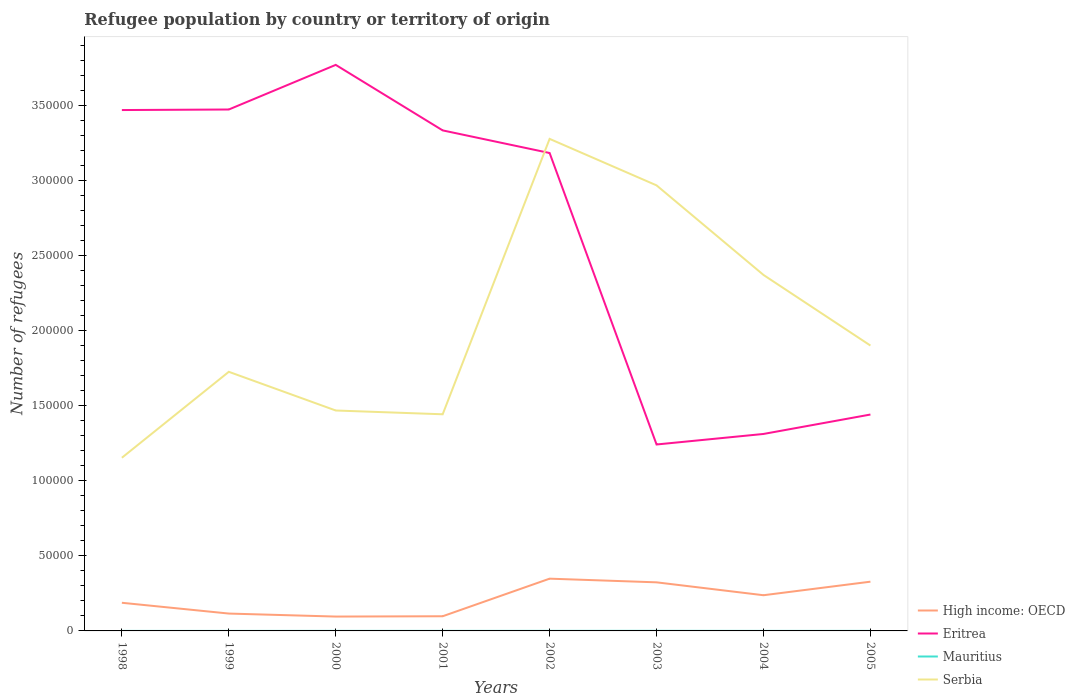How many different coloured lines are there?
Your answer should be compact. 4. Does the line corresponding to High income: OECD intersect with the line corresponding to Mauritius?
Your response must be concise. No. Is the number of lines equal to the number of legend labels?
Offer a terse response. Yes. Across all years, what is the maximum number of refugees in High income: OECD?
Ensure brevity in your answer.  9560. What is the total number of refugees in High income: OECD in the graph?
Provide a succinct answer. 1789. What is the difference between the highest and the second highest number of refugees in High income: OECD?
Offer a very short reply. 2.52e+04. What is the difference between the highest and the lowest number of refugees in Mauritius?
Keep it short and to the point. 4. Are the values on the major ticks of Y-axis written in scientific E-notation?
Offer a terse response. No. How many legend labels are there?
Your answer should be compact. 4. How are the legend labels stacked?
Give a very brief answer. Vertical. What is the title of the graph?
Give a very brief answer. Refugee population by country or territory of origin. What is the label or title of the Y-axis?
Provide a short and direct response. Number of refugees. What is the Number of refugees in High income: OECD in 1998?
Your response must be concise. 1.87e+04. What is the Number of refugees in Eritrea in 1998?
Your answer should be compact. 3.47e+05. What is the Number of refugees of Serbia in 1998?
Give a very brief answer. 1.15e+05. What is the Number of refugees of High income: OECD in 1999?
Your response must be concise. 1.16e+04. What is the Number of refugees of Eritrea in 1999?
Provide a succinct answer. 3.47e+05. What is the Number of refugees in Mauritius in 1999?
Make the answer very short. 8. What is the Number of refugees of Serbia in 1999?
Give a very brief answer. 1.73e+05. What is the Number of refugees of High income: OECD in 2000?
Your response must be concise. 9560. What is the Number of refugees of Eritrea in 2000?
Your answer should be very brief. 3.77e+05. What is the Number of refugees of Mauritius in 2000?
Keep it short and to the point. 35. What is the Number of refugees in Serbia in 2000?
Offer a terse response. 1.47e+05. What is the Number of refugees of High income: OECD in 2001?
Give a very brief answer. 9772. What is the Number of refugees of Eritrea in 2001?
Provide a succinct answer. 3.33e+05. What is the Number of refugees of Serbia in 2001?
Ensure brevity in your answer.  1.44e+05. What is the Number of refugees in High income: OECD in 2002?
Offer a terse response. 3.48e+04. What is the Number of refugees of Eritrea in 2002?
Ensure brevity in your answer.  3.18e+05. What is the Number of refugees of Serbia in 2002?
Your response must be concise. 3.28e+05. What is the Number of refugees in High income: OECD in 2003?
Ensure brevity in your answer.  3.23e+04. What is the Number of refugees in Eritrea in 2003?
Your answer should be very brief. 1.24e+05. What is the Number of refugees of Mauritius in 2003?
Keep it short and to the point. 61. What is the Number of refugees in Serbia in 2003?
Offer a terse response. 2.97e+05. What is the Number of refugees of High income: OECD in 2004?
Provide a succinct answer. 2.38e+04. What is the Number of refugees in Eritrea in 2004?
Offer a very short reply. 1.31e+05. What is the Number of refugees of Mauritius in 2004?
Ensure brevity in your answer.  19. What is the Number of refugees in Serbia in 2004?
Keep it short and to the point. 2.37e+05. What is the Number of refugees in High income: OECD in 2005?
Your answer should be compact. 3.28e+04. What is the Number of refugees of Eritrea in 2005?
Offer a very short reply. 1.44e+05. What is the Number of refugees in Serbia in 2005?
Give a very brief answer. 1.90e+05. Across all years, what is the maximum Number of refugees of High income: OECD?
Your answer should be compact. 3.48e+04. Across all years, what is the maximum Number of refugees in Eritrea?
Offer a very short reply. 3.77e+05. Across all years, what is the maximum Number of refugees of Mauritius?
Keep it short and to the point. 61. Across all years, what is the maximum Number of refugees of Serbia?
Provide a succinct answer. 3.28e+05. Across all years, what is the minimum Number of refugees of High income: OECD?
Make the answer very short. 9560. Across all years, what is the minimum Number of refugees of Eritrea?
Your answer should be very brief. 1.24e+05. Across all years, what is the minimum Number of refugees of Serbia?
Your answer should be very brief. 1.15e+05. What is the total Number of refugees of High income: OECD in the graph?
Give a very brief answer. 1.73e+05. What is the total Number of refugees of Eritrea in the graph?
Offer a very short reply. 2.12e+06. What is the total Number of refugees in Mauritius in the graph?
Your answer should be compact. 243. What is the total Number of refugees of Serbia in the graph?
Provide a short and direct response. 1.63e+06. What is the difference between the Number of refugees of High income: OECD in 1998 and that in 1999?
Make the answer very short. 7180. What is the difference between the Number of refugees of Eritrea in 1998 and that in 1999?
Offer a terse response. -357. What is the difference between the Number of refugees of Mauritius in 1998 and that in 1999?
Keep it short and to the point. 7. What is the difference between the Number of refugees of Serbia in 1998 and that in 1999?
Give a very brief answer. -5.72e+04. What is the difference between the Number of refugees in High income: OECD in 1998 and that in 2000?
Provide a succinct answer. 9181. What is the difference between the Number of refugees of Eritrea in 1998 and that in 2000?
Offer a very short reply. -3.01e+04. What is the difference between the Number of refugees of Mauritius in 1998 and that in 2000?
Offer a terse response. -20. What is the difference between the Number of refugees of Serbia in 1998 and that in 2000?
Your answer should be very brief. -3.15e+04. What is the difference between the Number of refugees of High income: OECD in 1998 and that in 2001?
Your answer should be compact. 8969. What is the difference between the Number of refugees of Eritrea in 1998 and that in 2001?
Make the answer very short. 1.36e+04. What is the difference between the Number of refugees of Serbia in 1998 and that in 2001?
Provide a succinct answer. -2.89e+04. What is the difference between the Number of refugees of High income: OECD in 1998 and that in 2002?
Provide a short and direct response. -1.60e+04. What is the difference between the Number of refugees in Eritrea in 1998 and that in 2002?
Offer a terse response. 2.86e+04. What is the difference between the Number of refugees of Serbia in 1998 and that in 2002?
Offer a terse response. -2.12e+05. What is the difference between the Number of refugees in High income: OECD in 1998 and that in 2003?
Keep it short and to the point. -1.36e+04. What is the difference between the Number of refugees in Eritrea in 1998 and that in 2003?
Your answer should be compact. 2.23e+05. What is the difference between the Number of refugees in Mauritius in 1998 and that in 2003?
Your answer should be very brief. -46. What is the difference between the Number of refugees of Serbia in 1998 and that in 2003?
Offer a very short reply. -1.81e+05. What is the difference between the Number of refugees in High income: OECD in 1998 and that in 2004?
Provide a short and direct response. -5022. What is the difference between the Number of refugees of Eritrea in 1998 and that in 2004?
Your response must be concise. 2.16e+05. What is the difference between the Number of refugees of Serbia in 1998 and that in 2004?
Offer a terse response. -1.22e+05. What is the difference between the Number of refugees of High income: OECD in 1998 and that in 2005?
Provide a short and direct response. -1.40e+04. What is the difference between the Number of refugees in Eritrea in 1998 and that in 2005?
Provide a succinct answer. 2.03e+05. What is the difference between the Number of refugees in Serbia in 1998 and that in 2005?
Keep it short and to the point. -7.47e+04. What is the difference between the Number of refugees of High income: OECD in 1999 and that in 2000?
Make the answer very short. 2001. What is the difference between the Number of refugees in Eritrea in 1999 and that in 2000?
Ensure brevity in your answer.  -2.97e+04. What is the difference between the Number of refugees in Serbia in 1999 and that in 2000?
Your answer should be compact. 2.58e+04. What is the difference between the Number of refugees of High income: OECD in 1999 and that in 2001?
Your response must be concise. 1789. What is the difference between the Number of refugees of Eritrea in 1999 and that in 2001?
Your answer should be compact. 1.39e+04. What is the difference between the Number of refugees in Serbia in 1999 and that in 2001?
Your response must be concise. 2.83e+04. What is the difference between the Number of refugees in High income: OECD in 1999 and that in 2002?
Give a very brief answer. -2.32e+04. What is the difference between the Number of refugees of Eritrea in 1999 and that in 2002?
Your answer should be very brief. 2.90e+04. What is the difference between the Number of refugees of Mauritius in 1999 and that in 2002?
Offer a very short reply. -35. What is the difference between the Number of refugees of Serbia in 1999 and that in 2002?
Your response must be concise. -1.55e+05. What is the difference between the Number of refugees in High income: OECD in 1999 and that in 2003?
Make the answer very short. -2.08e+04. What is the difference between the Number of refugees of Eritrea in 1999 and that in 2003?
Ensure brevity in your answer.  2.23e+05. What is the difference between the Number of refugees of Mauritius in 1999 and that in 2003?
Provide a succinct answer. -53. What is the difference between the Number of refugees in Serbia in 1999 and that in 2003?
Make the answer very short. -1.24e+05. What is the difference between the Number of refugees of High income: OECD in 1999 and that in 2004?
Your answer should be compact. -1.22e+04. What is the difference between the Number of refugees in Eritrea in 1999 and that in 2004?
Provide a short and direct response. 2.16e+05. What is the difference between the Number of refugees of Mauritius in 1999 and that in 2004?
Your answer should be very brief. -11. What is the difference between the Number of refugees in Serbia in 1999 and that in 2004?
Ensure brevity in your answer.  -6.45e+04. What is the difference between the Number of refugees of High income: OECD in 1999 and that in 2005?
Offer a terse response. -2.12e+04. What is the difference between the Number of refugees in Eritrea in 1999 and that in 2005?
Keep it short and to the point. 2.03e+05. What is the difference between the Number of refugees of Mauritius in 1999 and that in 2005?
Make the answer very short. -19. What is the difference between the Number of refugees of Serbia in 1999 and that in 2005?
Offer a very short reply. -1.75e+04. What is the difference between the Number of refugees in High income: OECD in 2000 and that in 2001?
Provide a short and direct response. -212. What is the difference between the Number of refugees in Eritrea in 2000 and that in 2001?
Keep it short and to the point. 4.36e+04. What is the difference between the Number of refugees of Serbia in 2000 and that in 2001?
Your answer should be compact. 2517. What is the difference between the Number of refugees in High income: OECD in 2000 and that in 2002?
Provide a succinct answer. -2.52e+04. What is the difference between the Number of refugees of Eritrea in 2000 and that in 2002?
Make the answer very short. 5.87e+04. What is the difference between the Number of refugees of Mauritius in 2000 and that in 2002?
Your answer should be very brief. -8. What is the difference between the Number of refugees in Serbia in 2000 and that in 2002?
Offer a very short reply. -1.81e+05. What is the difference between the Number of refugees in High income: OECD in 2000 and that in 2003?
Provide a short and direct response. -2.28e+04. What is the difference between the Number of refugees in Eritrea in 2000 and that in 2003?
Make the answer very short. 2.53e+05. What is the difference between the Number of refugees in Serbia in 2000 and that in 2003?
Provide a succinct answer. -1.50e+05. What is the difference between the Number of refugees of High income: OECD in 2000 and that in 2004?
Give a very brief answer. -1.42e+04. What is the difference between the Number of refugees of Eritrea in 2000 and that in 2004?
Offer a terse response. 2.46e+05. What is the difference between the Number of refugees of Mauritius in 2000 and that in 2004?
Ensure brevity in your answer.  16. What is the difference between the Number of refugees of Serbia in 2000 and that in 2004?
Your response must be concise. -9.03e+04. What is the difference between the Number of refugees in High income: OECD in 2000 and that in 2005?
Offer a terse response. -2.32e+04. What is the difference between the Number of refugees in Eritrea in 2000 and that in 2005?
Keep it short and to the point. 2.33e+05. What is the difference between the Number of refugees of Serbia in 2000 and that in 2005?
Your answer should be compact. -4.32e+04. What is the difference between the Number of refugees of High income: OECD in 2001 and that in 2002?
Make the answer very short. -2.50e+04. What is the difference between the Number of refugees in Eritrea in 2001 and that in 2002?
Give a very brief answer. 1.51e+04. What is the difference between the Number of refugees in Mauritius in 2001 and that in 2002?
Offer a very short reply. -8. What is the difference between the Number of refugees in Serbia in 2001 and that in 2002?
Give a very brief answer. -1.83e+05. What is the difference between the Number of refugees in High income: OECD in 2001 and that in 2003?
Offer a terse response. -2.26e+04. What is the difference between the Number of refugees of Eritrea in 2001 and that in 2003?
Offer a very short reply. 2.09e+05. What is the difference between the Number of refugees of Mauritius in 2001 and that in 2003?
Offer a very short reply. -26. What is the difference between the Number of refugees in Serbia in 2001 and that in 2003?
Offer a terse response. -1.52e+05. What is the difference between the Number of refugees in High income: OECD in 2001 and that in 2004?
Provide a succinct answer. -1.40e+04. What is the difference between the Number of refugees in Eritrea in 2001 and that in 2004?
Offer a terse response. 2.02e+05. What is the difference between the Number of refugees in Serbia in 2001 and that in 2004?
Offer a terse response. -9.28e+04. What is the difference between the Number of refugees of High income: OECD in 2001 and that in 2005?
Provide a short and direct response. -2.30e+04. What is the difference between the Number of refugees in Eritrea in 2001 and that in 2005?
Ensure brevity in your answer.  1.89e+05. What is the difference between the Number of refugees of Mauritius in 2001 and that in 2005?
Your answer should be compact. 8. What is the difference between the Number of refugees of Serbia in 2001 and that in 2005?
Give a very brief answer. -4.58e+04. What is the difference between the Number of refugees of High income: OECD in 2002 and that in 2003?
Keep it short and to the point. 2445. What is the difference between the Number of refugees of Eritrea in 2002 and that in 2003?
Your answer should be compact. 1.94e+05. What is the difference between the Number of refugees of Mauritius in 2002 and that in 2003?
Offer a terse response. -18. What is the difference between the Number of refugees in Serbia in 2002 and that in 2003?
Offer a very short reply. 3.10e+04. What is the difference between the Number of refugees of High income: OECD in 2002 and that in 2004?
Ensure brevity in your answer.  1.10e+04. What is the difference between the Number of refugees in Eritrea in 2002 and that in 2004?
Your answer should be very brief. 1.87e+05. What is the difference between the Number of refugees in Serbia in 2002 and that in 2004?
Offer a terse response. 9.06e+04. What is the difference between the Number of refugees in High income: OECD in 2002 and that in 2005?
Keep it short and to the point. 2007. What is the difference between the Number of refugees of Eritrea in 2002 and that in 2005?
Keep it short and to the point. 1.74e+05. What is the difference between the Number of refugees of Mauritius in 2002 and that in 2005?
Offer a terse response. 16. What is the difference between the Number of refugees of Serbia in 2002 and that in 2005?
Offer a very short reply. 1.38e+05. What is the difference between the Number of refugees of High income: OECD in 2003 and that in 2004?
Your response must be concise. 8583. What is the difference between the Number of refugees of Eritrea in 2003 and that in 2004?
Ensure brevity in your answer.  -7010. What is the difference between the Number of refugees of Serbia in 2003 and that in 2004?
Keep it short and to the point. 5.96e+04. What is the difference between the Number of refugees in High income: OECD in 2003 and that in 2005?
Give a very brief answer. -438. What is the difference between the Number of refugees of Eritrea in 2003 and that in 2005?
Provide a succinct answer. -1.99e+04. What is the difference between the Number of refugees of Mauritius in 2003 and that in 2005?
Provide a succinct answer. 34. What is the difference between the Number of refugees of Serbia in 2003 and that in 2005?
Your response must be concise. 1.07e+05. What is the difference between the Number of refugees in High income: OECD in 2004 and that in 2005?
Provide a short and direct response. -9021. What is the difference between the Number of refugees in Eritrea in 2004 and that in 2005?
Your response must be concise. -1.29e+04. What is the difference between the Number of refugees of Serbia in 2004 and that in 2005?
Give a very brief answer. 4.70e+04. What is the difference between the Number of refugees of High income: OECD in 1998 and the Number of refugees of Eritrea in 1999?
Provide a short and direct response. -3.28e+05. What is the difference between the Number of refugees in High income: OECD in 1998 and the Number of refugees in Mauritius in 1999?
Ensure brevity in your answer.  1.87e+04. What is the difference between the Number of refugees of High income: OECD in 1998 and the Number of refugees of Serbia in 1999?
Give a very brief answer. -1.54e+05. What is the difference between the Number of refugees of Eritrea in 1998 and the Number of refugees of Mauritius in 1999?
Keep it short and to the point. 3.47e+05. What is the difference between the Number of refugees of Eritrea in 1998 and the Number of refugees of Serbia in 1999?
Your answer should be very brief. 1.74e+05. What is the difference between the Number of refugees in Mauritius in 1998 and the Number of refugees in Serbia in 1999?
Your response must be concise. -1.72e+05. What is the difference between the Number of refugees of High income: OECD in 1998 and the Number of refugees of Eritrea in 2000?
Provide a succinct answer. -3.58e+05. What is the difference between the Number of refugees of High income: OECD in 1998 and the Number of refugees of Mauritius in 2000?
Provide a succinct answer. 1.87e+04. What is the difference between the Number of refugees in High income: OECD in 1998 and the Number of refugees in Serbia in 2000?
Make the answer very short. -1.28e+05. What is the difference between the Number of refugees of Eritrea in 1998 and the Number of refugees of Mauritius in 2000?
Give a very brief answer. 3.47e+05. What is the difference between the Number of refugees of Eritrea in 1998 and the Number of refugees of Serbia in 2000?
Keep it short and to the point. 2.00e+05. What is the difference between the Number of refugees in Mauritius in 1998 and the Number of refugees in Serbia in 2000?
Ensure brevity in your answer.  -1.47e+05. What is the difference between the Number of refugees in High income: OECD in 1998 and the Number of refugees in Eritrea in 2001?
Offer a very short reply. -3.14e+05. What is the difference between the Number of refugees of High income: OECD in 1998 and the Number of refugees of Mauritius in 2001?
Make the answer very short. 1.87e+04. What is the difference between the Number of refugees of High income: OECD in 1998 and the Number of refugees of Serbia in 2001?
Ensure brevity in your answer.  -1.25e+05. What is the difference between the Number of refugees in Eritrea in 1998 and the Number of refugees in Mauritius in 2001?
Provide a short and direct response. 3.47e+05. What is the difference between the Number of refugees in Eritrea in 1998 and the Number of refugees in Serbia in 2001?
Keep it short and to the point. 2.03e+05. What is the difference between the Number of refugees in Mauritius in 1998 and the Number of refugees in Serbia in 2001?
Give a very brief answer. -1.44e+05. What is the difference between the Number of refugees of High income: OECD in 1998 and the Number of refugees of Eritrea in 2002?
Provide a short and direct response. -2.99e+05. What is the difference between the Number of refugees in High income: OECD in 1998 and the Number of refugees in Mauritius in 2002?
Keep it short and to the point. 1.87e+04. What is the difference between the Number of refugees of High income: OECD in 1998 and the Number of refugees of Serbia in 2002?
Keep it short and to the point. -3.09e+05. What is the difference between the Number of refugees of Eritrea in 1998 and the Number of refugees of Mauritius in 2002?
Provide a short and direct response. 3.47e+05. What is the difference between the Number of refugees of Eritrea in 1998 and the Number of refugees of Serbia in 2002?
Offer a terse response. 1.92e+04. What is the difference between the Number of refugees of Mauritius in 1998 and the Number of refugees of Serbia in 2002?
Make the answer very short. -3.28e+05. What is the difference between the Number of refugees in High income: OECD in 1998 and the Number of refugees in Eritrea in 2003?
Your answer should be very brief. -1.05e+05. What is the difference between the Number of refugees in High income: OECD in 1998 and the Number of refugees in Mauritius in 2003?
Provide a short and direct response. 1.87e+04. What is the difference between the Number of refugees in High income: OECD in 1998 and the Number of refugees in Serbia in 2003?
Make the answer very short. -2.78e+05. What is the difference between the Number of refugees of Eritrea in 1998 and the Number of refugees of Mauritius in 2003?
Provide a short and direct response. 3.47e+05. What is the difference between the Number of refugees in Eritrea in 1998 and the Number of refugees in Serbia in 2003?
Offer a very short reply. 5.01e+04. What is the difference between the Number of refugees of Mauritius in 1998 and the Number of refugees of Serbia in 2003?
Ensure brevity in your answer.  -2.97e+05. What is the difference between the Number of refugees of High income: OECD in 1998 and the Number of refugees of Eritrea in 2004?
Your answer should be compact. -1.12e+05. What is the difference between the Number of refugees in High income: OECD in 1998 and the Number of refugees in Mauritius in 2004?
Your answer should be compact. 1.87e+04. What is the difference between the Number of refugees of High income: OECD in 1998 and the Number of refugees of Serbia in 2004?
Provide a succinct answer. -2.18e+05. What is the difference between the Number of refugees in Eritrea in 1998 and the Number of refugees in Mauritius in 2004?
Offer a very short reply. 3.47e+05. What is the difference between the Number of refugees in Eritrea in 1998 and the Number of refugees in Serbia in 2004?
Offer a terse response. 1.10e+05. What is the difference between the Number of refugees of Mauritius in 1998 and the Number of refugees of Serbia in 2004?
Offer a very short reply. -2.37e+05. What is the difference between the Number of refugees of High income: OECD in 1998 and the Number of refugees of Eritrea in 2005?
Provide a succinct answer. -1.25e+05. What is the difference between the Number of refugees in High income: OECD in 1998 and the Number of refugees in Mauritius in 2005?
Make the answer very short. 1.87e+04. What is the difference between the Number of refugees of High income: OECD in 1998 and the Number of refugees of Serbia in 2005?
Provide a short and direct response. -1.71e+05. What is the difference between the Number of refugees in Eritrea in 1998 and the Number of refugees in Mauritius in 2005?
Offer a terse response. 3.47e+05. What is the difference between the Number of refugees in Eritrea in 1998 and the Number of refugees in Serbia in 2005?
Your answer should be very brief. 1.57e+05. What is the difference between the Number of refugees of Mauritius in 1998 and the Number of refugees of Serbia in 2005?
Keep it short and to the point. -1.90e+05. What is the difference between the Number of refugees of High income: OECD in 1999 and the Number of refugees of Eritrea in 2000?
Keep it short and to the point. -3.65e+05. What is the difference between the Number of refugees in High income: OECD in 1999 and the Number of refugees in Mauritius in 2000?
Make the answer very short. 1.15e+04. What is the difference between the Number of refugees of High income: OECD in 1999 and the Number of refugees of Serbia in 2000?
Provide a short and direct response. -1.35e+05. What is the difference between the Number of refugees in Eritrea in 1999 and the Number of refugees in Mauritius in 2000?
Your answer should be very brief. 3.47e+05. What is the difference between the Number of refugees in Eritrea in 1999 and the Number of refugees in Serbia in 2000?
Provide a succinct answer. 2.00e+05. What is the difference between the Number of refugees in Mauritius in 1999 and the Number of refugees in Serbia in 2000?
Your response must be concise. -1.47e+05. What is the difference between the Number of refugees in High income: OECD in 1999 and the Number of refugees in Eritrea in 2001?
Give a very brief answer. -3.22e+05. What is the difference between the Number of refugees of High income: OECD in 1999 and the Number of refugees of Mauritius in 2001?
Provide a short and direct response. 1.15e+04. What is the difference between the Number of refugees of High income: OECD in 1999 and the Number of refugees of Serbia in 2001?
Offer a terse response. -1.33e+05. What is the difference between the Number of refugees of Eritrea in 1999 and the Number of refugees of Mauritius in 2001?
Make the answer very short. 3.47e+05. What is the difference between the Number of refugees of Eritrea in 1999 and the Number of refugees of Serbia in 2001?
Your response must be concise. 2.03e+05. What is the difference between the Number of refugees of Mauritius in 1999 and the Number of refugees of Serbia in 2001?
Keep it short and to the point. -1.44e+05. What is the difference between the Number of refugees in High income: OECD in 1999 and the Number of refugees in Eritrea in 2002?
Offer a terse response. -3.07e+05. What is the difference between the Number of refugees of High income: OECD in 1999 and the Number of refugees of Mauritius in 2002?
Offer a very short reply. 1.15e+04. What is the difference between the Number of refugees of High income: OECD in 1999 and the Number of refugees of Serbia in 2002?
Ensure brevity in your answer.  -3.16e+05. What is the difference between the Number of refugees in Eritrea in 1999 and the Number of refugees in Mauritius in 2002?
Your answer should be very brief. 3.47e+05. What is the difference between the Number of refugees in Eritrea in 1999 and the Number of refugees in Serbia in 2002?
Your response must be concise. 1.96e+04. What is the difference between the Number of refugees in Mauritius in 1999 and the Number of refugees in Serbia in 2002?
Make the answer very short. -3.28e+05. What is the difference between the Number of refugees of High income: OECD in 1999 and the Number of refugees of Eritrea in 2003?
Ensure brevity in your answer.  -1.13e+05. What is the difference between the Number of refugees of High income: OECD in 1999 and the Number of refugees of Mauritius in 2003?
Offer a terse response. 1.15e+04. What is the difference between the Number of refugees of High income: OECD in 1999 and the Number of refugees of Serbia in 2003?
Provide a succinct answer. -2.85e+05. What is the difference between the Number of refugees in Eritrea in 1999 and the Number of refugees in Mauritius in 2003?
Provide a short and direct response. 3.47e+05. What is the difference between the Number of refugees in Eritrea in 1999 and the Number of refugees in Serbia in 2003?
Your answer should be compact. 5.05e+04. What is the difference between the Number of refugees of Mauritius in 1999 and the Number of refugees of Serbia in 2003?
Give a very brief answer. -2.97e+05. What is the difference between the Number of refugees in High income: OECD in 1999 and the Number of refugees in Eritrea in 2004?
Keep it short and to the point. -1.20e+05. What is the difference between the Number of refugees of High income: OECD in 1999 and the Number of refugees of Mauritius in 2004?
Keep it short and to the point. 1.15e+04. What is the difference between the Number of refugees of High income: OECD in 1999 and the Number of refugees of Serbia in 2004?
Your answer should be compact. -2.25e+05. What is the difference between the Number of refugees of Eritrea in 1999 and the Number of refugees of Mauritius in 2004?
Give a very brief answer. 3.47e+05. What is the difference between the Number of refugees in Eritrea in 1999 and the Number of refugees in Serbia in 2004?
Ensure brevity in your answer.  1.10e+05. What is the difference between the Number of refugees of Mauritius in 1999 and the Number of refugees of Serbia in 2004?
Make the answer very short. -2.37e+05. What is the difference between the Number of refugees of High income: OECD in 1999 and the Number of refugees of Eritrea in 2005?
Give a very brief answer. -1.33e+05. What is the difference between the Number of refugees of High income: OECD in 1999 and the Number of refugees of Mauritius in 2005?
Give a very brief answer. 1.15e+04. What is the difference between the Number of refugees of High income: OECD in 1999 and the Number of refugees of Serbia in 2005?
Your response must be concise. -1.78e+05. What is the difference between the Number of refugees in Eritrea in 1999 and the Number of refugees in Mauritius in 2005?
Provide a succinct answer. 3.47e+05. What is the difference between the Number of refugees of Eritrea in 1999 and the Number of refugees of Serbia in 2005?
Offer a very short reply. 1.57e+05. What is the difference between the Number of refugees in Mauritius in 1999 and the Number of refugees in Serbia in 2005?
Give a very brief answer. -1.90e+05. What is the difference between the Number of refugees in High income: OECD in 2000 and the Number of refugees in Eritrea in 2001?
Provide a succinct answer. -3.24e+05. What is the difference between the Number of refugees in High income: OECD in 2000 and the Number of refugees in Mauritius in 2001?
Ensure brevity in your answer.  9525. What is the difference between the Number of refugees of High income: OECD in 2000 and the Number of refugees of Serbia in 2001?
Make the answer very short. -1.35e+05. What is the difference between the Number of refugees in Eritrea in 2000 and the Number of refugees in Mauritius in 2001?
Keep it short and to the point. 3.77e+05. What is the difference between the Number of refugees of Eritrea in 2000 and the Number of refugees of Serbia in 2001?
Provide a short and direct response. 2.33e+05. What is the difference between the Number of refugees in Mauritius in 2000 and the Number of refugees in Serbia in 2001?
Offer a very short reply. -1.44e+05. What is the difference between the Number of refugees of High income: OECD in 2000 and the Number of refugees of Eritrea in 2002?
Offer a very short reply. -3.09e+05. What is the difference between the Number of refugees in High income: OECD in 2000 and the Number of refugees in Mauritius in 2002?
Offer a very short reply. 9517. What is the difference between the Number of refugees of High income: OECD in 2000 and the Number of refugees of Serbia in 2002?
Give a very brief answer. -3.18e+05. What is the difference between the Number of refugees in Eritrea in 2000 and the Number of refugees in Mauritius in 2002?
Give a very brief answer. 3.77e+05. What is the difference between the Number of refugees in Eritrea in 2000 and the Number of refugees in Serbia in 2002?
Provide a short and direct response. 4.93e+04. What is the difference between the Number of refugees of Mauritius in 2000 and the Number of refugees of Serbia in 2002?
Give a very brief answer. -3.28e+05. What is the difference between the Number of refugees of High income: OECD in 2000 and the Number of refugees of Eritrea in 2003?
Offer a terse response. -1.15e+05. What is the difference between the Number of refugees in High income: OECD in 2000 and the Number of refugees in Mauritius in 2003?
Provide a succinct answer. 9499. What is the difference between the Number of refugees in High income: OECD in 2000 and the Number of refugees in Serbia in 2003?
Offer a terse response. -2.87e+05. What is the difference between the Number of refugees of Eritrea in 2000 and the Number of refugees of Mauritius in 2003?
Keep it short and to the point. 3.77e+05. What is the difference between the Number of refugees of Eritrea in 2000 and the Number of refugees of Serbia in 2003?
Provide a succinct answer. 8.02e+04. What is the difference between the Number of refugees in Mauritius in 2000 and the Number of refugees in Serbia in 2003?
Provide a succinct answer. -2.97e+05. What is the difference between the Number of refugees of High income: OECD in 2000 and the Number of refugees of Eritrea in 2004?
Make the answer very short. -1.22e+05. What is the difference between the Number of refugees in High income: OECD in 2000 and the Number of refugees in Mauritius in 2004?
Keep it short and to the point. 9541. What is the difference between the Number of refugees in High income: OECD in 2000 and the Number of refugees in Serbia in 2004?
Offer a terse response. -2.27e+05. What is the difference between the Number of refugees in Eritrea in 2000 and the Number of refugees in Mauritius in 2004?
Ensure brevity in your answer.  3.77e+05. What is the difference between the Number of refugees in Eritrea in 2000 and the Number of refugees in Serbia in 2004?
Give a very brief answer. 1.40e+05. What is the difference between the Number of refugees in Mauritius in 2000 and the Number of refugees in Serbia in 2004?
Offer a terse response. -2.37e+05. What is the difference between the Number of refugees in High income: OECD in 2000 and the Number of refugees in Eritrea in 2005?
Provide a short and direct response. -1.35e+05. What is the difference between the Number of refugees in High income: OECD in 2000 and the Number of refugees in Mauritius in 2005?
Offer a terse response. 9533. What is the difference between the Number of refugees of High income: OECD in 2000 and the Number of refugees of Serbia in 2005?
Provide a succinct answer. -1.80e+05. What is the difference between the Number of refugees of Eritrea in 2000 and the Number of refugees of Mauritius in 2005?
Offer a terse response. 3.77e+05. What is the difference between the Number of refugees in Eritrea in 2000 and the Number of refugees in Serbia in 2005?
Ensure brevity in your answer.  1.87e+05. What is the difference between the Number of refugees in Mauritius in 2000 and the Number of refugees in Serbia in 2005?
Make the answer very short. -1.90e+05. What is the difference between the Number of refugees of High income: OECD in 2001 and the Number of refugees of Eritrea in 2002?
Ensure brevity in your answer.  -3.08e+05. What is the difference between the Number of refugees in High income: OECD in 2001 and the Number of refugees in Mauritius in 2002?
Offer a terse response. 9729. What is the difference between the Number of refugees of High income: OECD in 2001 and the Number of refugees of Serbia in 2002?
Ensure brevity in your answer.  -3.18e+05. What is the difference between the Number of refugees in Eritrea in 2001 and the Number of refugees in Mauritius in 2002?
Your answer should be compact. 3.33e+05. What is the difference between the Number of refugees in Eritrea in 2001 and the Number of refugees in Serbia in 2002?
Offer a very short reply. 5642. What is the difference between the Number of refugees of Mauritius in 2001 and the Number of refugees of Serbia in 2002?
Your answer should be very brief. -3.28e+05. What is the difference between the Number of refugees in High income: OECD in 2001 and the Number of refugees in Eritrea in 2003?
Your response must be concise. -1.14e+05. What is the difference between the Number of refugees in High income: OECD in 2001 and the Number of refugees in Mauritius in 2003?
Offer a very short reply. 9711. What is the difference between the Number of refugees in High income: OECD in 2001 and the Number of refugees in Serbia in 2003?
Provide a short and direct response. -2.87e+05. What is the difference between the Number of refugees of Eritrea in 2001 and the Number of refugees of Mauritius in 2003?
Provide a short and direct response. 3.33e+05. What is the difference between the Number of refugees of Eritrea in 2001 and the Number of refugees of Serbia in 2003?
Provide a succinct answer. 3.66e+04. What is the difference between the Number of refugees in Mauritius in 2001 and the Number of refugees in Serbia in 2003?
Give a very brief answer. -2.97e+05. What is the difference between the Number of refugees of High income: OECD in 2001 and the Number of refugees of Eritrea in 2004?
Give a very brief answer. -1.21e+05. What is the difference between the Number of refugees in High income: OECD in 2001 and the Number of refugees in Mauritius in 2004?
Provide a short and direct response. 9753. What is the difference between the Number of refugees of High income: OECD in 2001 and the Number of refugees of Serbia in 2004?
Make the answer very short. -2.27e+05. What is the difference between the Number of refugees in Eritrea in 2001 and the Number of refugees in Mauritius in 2004?
Your answer should be compact. 3.33e+05. What is the difference between the Number of refugees of Eritrea in 2001 and the Number of refugees of Serbia in 2004?
Offer a very short reply. 9.62e+04. What is the difference between the Number of refugees of Mauritius in 2001 and the Number of refugees of Serbia in 2004?
Provide a short and direct response. -2.37e+05. What is the difference between the Number of refugees in High income: OECD in 2001 and the Number of refugees in Eritrea in 2005?
Your response must be concise. -1.34e+05. What is the difference between the Number of refugees of High income: OECD in 2001 and the Number of refugees of Mauritius in 2005?
Your answer should be compact. 9745. What is the difference between the Number of refugees of High income: OECD in 2001 and the Number of refugees of Serbia in 2005?
Offer a very short reply. -1.80e+05. What is the difference between the Number of refugees of Eritrea in 2001 and the Number of refugees of Mauritius in 2005?
Your answer should be compact. 3.33e+05. What is the difference between the Number of refugees in Eritrea in 2001 and the Number of refugees in Serbia in 2005?
Offer a very short reply. 1.43e+05. What is the difference between the Number of refugees of Mauritius in 2001 and the Number of refugees of Serbia in 2005?
Ensure brevity in your answer.  -1.90e+05. What is the difference between the Number of refugees of High income: OECD in 2002 and the Number of refugees of Eritrea in 2003?
Keep it short and to the point. -8.93e+04. What is the difference between the Number of refugees of High income: OECD in 2002 and the Number of refugees of Mauritius in 2003?
Offer a terse response. 3.47e+04. What is the difference between the Number of refugees of High income: OECD in 2002 and the Number of refugees of Serbia in 2003?
Offer a terse response. -2.62e+05. What is the difference between the Number of refugees of Eritrea in 2002 and the Number of refugees of Mauritius in 2003?
Offer a very short reply. 3.18e+05. What is the difference between the Number of refugees of Eritrea in 2002 and the Number of refugees of Serbia in 2003?
Offer a very short reply. 2.15e+04. What is the difference between the Number of refugees of Mauritius in 2002 and the Number of refugees of Serbia in 2003?
Make the answer very short. -2.97e+05. What is the difference between the Number of refugees of High income: OECD in 2002 and the Number of refugees of Eritrea in 2004?
Keep it short and to the point. -9.63e+04. What is the difference between the Number of refugees in High income: OECD in 2002 and the Number of refugees in Mauritius in 2004?
Your answer should be very brief. 3.48e+04. What is the difference between the Number of refugees in High income: OECD in 2002 and the Number of refugees in Serbia in 2004?
Your answer should be very brief. -2.02e+05. What is the difference between the Number of refugees in Eritrea in 2002 and the Number of refugees in Mauritius in 2004?
Your answer should be very brief. 3.18e+05. What is the difference between the Number of refugees of Eritrea in 2002 and the Number of refugees of Serbia in 2004?
Keep it short and to the point. 8.12e+04. What is the difference between the Number of refugees in Mauritius in 2002 and the Number of refugees in Serbia in 2004?
Your response must be concise. -2.37e+05. What is the difference between the Number of refugees of High income: OECD in 2002 and the Number of refugees of Eritrea in 2005?
Provide a short and direct response. -1.09e+05. What is the difference between the Number of refugees in High income: OECD in 2002 and the Number of refugees in Mauritius in 2005?
Your answer should be very brief. 3.48e+04. What is the difference between the Number of refugees in High income: OECD in 2002 and the Number of refugees in Serbia in 2005?
Your answer should be very brief. -1.55e+05. What is the difference between the Number of refugees of Eritrea in 2002 and the Number of refugees of Mauritius in 2005?
Your answer should be compact. 3.18e+05. What is the difference between the Number of refugees in Eritrea in 2002 and the Number of refugees in Serbia in 2005?
Your answer should be very brief. 1.28e+05. What is the difference between the Number of refugees in Mauritius in 2002 and the Number of refugees in Serbia in 2005?
Your answer should be compact. -1.90e+05. What is the difference between the Number of refugees in High income: OECD in 2003 and the Number of refugees in Eritrea in 2004?
Make the answer very short. -9.88e+04. What is the difference between the Number of refugees of High income: OECD in 2003 and the Number of refugees of Mauritius in 2004?
Your answer should be very brief. 3.23e+04. What is the difference between the Number of refugees of High income: OECD in 2003 and the Number of refugees of Serbia in 2004?
Make the answer very short. -2.05e+05. What is the difference between the Number of refugees of Eritrea in 2003 and the Number of refugees of Mauritius in 2004?
Offer a very short reply. 1.24e+05. What is the difference between the Number of refugees of Eritrea in 2003 and the Number of refugees of Serbia in 2004?
Keep it short and to the point. -1.13e+05. What is the difference between the Number of refugees in Mauritius in 2003 and the Number of refugees in Serbia in 2004?
Give a very brief answer. -2.37e+05. What is the difference between the Number of refugees in High income: OECD in 2003 and the Number of refugees in Eritrea in 2005?
Your answer should be very brief. -1.12e+05. What is the difference between the Number of refugees in High income: OECD in 2003 and the Number of refugees in Mauritius in 2005?
Your response must be concise. 3.23e+04. What is the difference between the Number of refugees in High income: OECD in 2003 and the Number of refugees in Serbia in 2005?
Give a very brief answer. -1.58e+05. What is the difference between the Number of refugees in Eritrea in 2003 and the Number of refugees in Mauritius in 2005?
Provide a short and direct response. 1.24e+05. What is the difference between the Number of refugees of Eritrea in 2003 and the Number of refugees of Serbia in 2005?
Your answer should be compact. -6.59e+04. What is the difference between the Number of refugees of Mauritius in 2003 and the Number of refugees of Serbia in 2005?
Your answer should be compact. -1.90e+05. What is the difference between the Number of refugees of High income: OECD in 2004 and the Number of refugees of Eritrea in 2005?
Your response must be concise. -1.20e+05. What is the difference between the Number of refugees in High income: OECD in 2004 and the Number of refugees in Mauritius in 2005?
Keep it short and to the point. 2.37e+04. What is the difference between the Number of refugees in High income: OECD in 2004 and the Number of refugees in Serbia in 2005?
Your answer should be very brief. -1.66e+05. What is the difference between the Number of refugees of Eritrea in 2004 and the Number of refugees of Mauritius in 2005?
Your answer should be compact. 1.31e+05. What is the difference between the Number of refugees of Eritrea in 2004 and the Number of refugees of Serbia in 2005?
Your answer should be very brief. -5.89e+04. What is the difference between the Number of refugees of Mauritius in 2004 and the Number of refugees of Serbia in 2005?
Make the answer very short. -1.90e+05. What is the average Number of refugees of High income: OECD per year?
Your answer should be compact. 2.17e+04. What is the average Number of refugees in Eritrea per year?
Your answer should be very brief. 2.65e+05. What is the average Number of refugees in Mauritius per year?
Offer a very short reply. 30.38. What is the average Number of refugees in Serbia per year?
Give a very brief answer. 2.04e+05. In the year 1998, what is the difference between the Number of refugees in High income: OECD and Number of refugees in Eritrea?
Make the answer very short. -3.28e+05. In the year 1998, what is the difference between the Number of refugees of High income: OECD and Number of refugees of Mauritius?
Offer a terse response. 1.87e+04. In the year 1998, what is the difference between the Number of refugees of High income: OECD and Number of refugees of Serbia?
Offer a terse response. -9.66e+04. In the year 1998, what is the difference between the Number of refugees in Eritrea and Number of refugees in Mauritius?
Offer a terse response. 3.47e+05. In the year 1998, what is the difference between the Number of refugees in Eritrea and Number of refugees in Serbia?
Offer a terse response. 2.31e+05. In the year 1998, what is the difference between the Number of refugees in Mauritius and Number of refugees in Serbia?
Keep it short and to the point. -1.15e+05. In the year 1999, what is the difference between the Number of refugees of High income: OECD and Number of refugees of Eritrea?
Keep it short and to the point. -3.36e+05. In the year 1999, what is the difference between the Number of refugees in High income: OECD and Number of refugees in Mauritius?
Provide a short and direct response. 1.16e+04. In the year 1999, what is the difference between the Number of refugees in High income: OECD and Number of refugees in Serbia?
Offer a very short reply. -1.61e+05. In the year 1999, what is the difference between the Number of refugees in Eritrea and Number of refugees in Mauritius?
Your answer should be very brief. 3.47e+05. In the year 1999, what is the difference between the Number of refugees in Eritrea and Number of refugees in Serbia?
Offer a very short reply. 1.75e+05. In the year 1999, what is the difference between the Number of refugees in Mauritius and Number of refugees in Serbia?
Give a very brief answer. -1.73e+05. In the year 2000, what is the difference between the Number of refugees in High income: OECD and Number of refugees in Eritrea?
Offer a very short reply. -3.67e+05. In the year 2000, what is the difference between the Number of refugees in High income: OECD and Number of refugees in Mauritius?
Offer a very short reply. 9525. In the year 2000, what is the difference between the Number of refugees of High income: OECD and Number of refugees of Serbia?
Offer a very short reply. -1.37e+05. In the year 2000, what is the difference between the Number of refugees in Eritrea and Number of refugees in Mauritius?
Your response must be concise. 3.77e+05. In the year 2000, what is the difference between the Number of refugees in Eritrea and Number of refugees in Serbia?
Make the answer very short. 2.30e+05. In the year 2000, what is the difference between the Number of refugees of Mauritius and Number of refugees of Serbia?
Make the answer very short. -1.47e+05. In the year 2001, what is the difference between the Number of refugees of High income: OECD and Number of refugees of Eritrea?
Provide a short and direct response. -3.23e+05. In the year 2001, what is the difference between the Number of refugees of High income: OECD and Number of refugees of Mauritius?
Keep it short and to the point. 9737. In the year 2001, what is the difference between the Number of refugees of High income: OECD and Number of refugees of Serbia?
Your answer should be compact. -1.34e+05. In the year 2001, what is the difference between the Number of refugees in Eritrea and Number of refugees in Mauritius?
Offer a very short reply. 3.33e+05. In the year 2001, what is the difference between the Number of refugees of Eritrea and Number of refugees of Serbia?
Your answer should be compact. 1.89e+05. In the year 2001, what is the difference between the Number of refugees in Mauritius and Number of refugees in Serbia?
Provide a succinct answer. -1.44e+05. In the year 2002, what is the difference between the Number of refugees of High income: OECD and Number of refugees of Eritrea?
Offer a very short reply. -2.83e+05. In the year 2002, what is the difference between the Number of refugees of High income: OECD and Number of refugees of Mauritius?
Ensure brevity in your answer.  3.47e+04. In the year 2002, what is the difference between the Number of refugees in High income: OECD and Number of refugees in Serbia?
Ensure brevity in your answer.  -2.93e+05. In the year 2002, what is the difference between the Number of refugees in Eritrea and Number of refugees in Mauritius?
Provide a short and direct response. 3.18e+05. In the year 2002, what is the difference between the Number of refugees in Eritrea and Number of refugees in Serbia?
Your answer should be compact. -9411. In the year 2002, what is the difference between the Number of refugees in Mauritius and Number of refugees in Serbia?
Offer a very short reply. -3.28e+05. In the year 2003, what is the difference between the Number of refugees of High income: OECD and Number of refugees of Eritrea?
Provide a short and direct response. -9.18e+04. In the year 2003, what is the difference between the Number of refugees of High income: OECD and Number of refugees of Mauritius?
Your response must be concise. 3.23e+04. In the year 2003, what is the difference between the Number of refugees in High income: OECD and Number of refugees in Serbia?
Provide a succinct answer. -2.64e+05. In the year 2003, what is the difference between the Number of refugees in Eritrea and Number of refugees in Mauritius?
Your response must be concise. 1.24e+05. In the year 2003, what is the difference between the Number of refugees of Eritrea and Number of refugees of Serbia?
Offer a very short reply. -1.73e+05. In the year 2003, what is the difference between the Number of refugees in Mauritius and Number of refugees in Serbia?
Your answer should be very brief. -2.97e+05. In the year 2004, what is the difference between the Number of refugees of High income: OECD and Number of refugees of Eritrea?
Provide a succinct answer. -1.07e+05. In the year 2004, what is the difference between the Number of refugees of High income: OECD and Number of refugees of Mauritius?
Offer a terse response. 2.37e+04. In the year 2004, what is the difference between the Number of refugees of High income: OECD and Number of refugees of Serbia?
Make the answer very short. -2.13e+05. In the year 2004, what is the difference between the Number of refugees of Eritrea and Number of refugees of Mauritius?
Ensure brevity in your answer.  1.31e+05. In the year 2004, what is the difference between the Number of refugees of Eritrea and Number of refugees of Serbia?
Give a very brief answer. -1.06e+05. In the year 2004, what is the difference between the Number of refugees in Mauritius and Number of refugees in Serbia?
Your answer should be compact. -2.37e+05. In the year 2005, what is the difference between the Number of refugees in High income: OECD and Number of refugees in Eritrea?
Keep it short and to the point. -1.11e+05. In the year 2005, what is the difference between the Number of refugees in High income: OECD and Number of refugees in Mauritius?
Your answer should be compact. 3.28e+04. In the year 2005, what is the difference between the Number of refugees in High income: OECD and Number of refugees in Serbia?
Your response must be concise. -1.57e+05. In the year 2005, what is the difference between the Number of refugees in Eritrea and Number of refugees in Mauritius?
Make the answer very short. 1.44e+05. In the year 2005, what is the difference between the Number of refugees in Eritrea and Number of refugees in Serbia?
Make the answer very short. -4.59e+04. In the year 2005, what is the difference between the Number of refugees in Mauritius and Number of refugees in Serbia?
Keep it short and to the point. -1.90e+05. What is the ratio of the Number of refugees in High income: OECD in 1998 to that in 1999?
Provide a short and direct response. 1.62. What is the ratio of the Number of refugees in Eritrea in 1998 to that in 1999?
Provide a succinct answer. 1. What is the ratio of the Number of refugees in Mauritius in 1998 to that in 1999?
Your answer should be very brief. 1.88. What is the ratio of the Number of refugees in Serbia in 1998 to that in 1999?
Give a very brief answer. 0.67. What is the ratio of the Number of refugees in High income: OECD in 1998 to that in 2000?
Provide a succinct answer. 1.96. What is the ratio of the Number of refugees in Eritrea in 1998 to that in 2000?
Your answer should be very brief. 0.92. What is the ratio of the Number of refugees in Mauritius in 1998 to that in 2000?
Make the answer very short. 0.43. What is the ratio of the Number of refugees of Serbia in 1998 to that in 2000?
Provide a succinct answer. 0.79. What is the ratio of the Number of refugees of High income: OECD in 1998 to that in 2001?
Offer a very short reply. 1.92. What is the ratio of the Number of refugees in Eritrea in 1998 to that in 2001?
Ensure brevity in your answer.  1.04. What is the ratio of the Number of refugees of Mauritius in 1998 to that in 2001?
Your answer should be compact. 0.43. What is the ratio of the Number of refugees in Serbia in 1998 to that in 2001?
Your response must be concise. 0.8. What is the ratio of the Number of refugees of High income: OECD in 1998 to that in 2002?
Your response must be concise. 0.54. What is the ratio of the Number of refugees of Eritrea in 1998 to that in 2002?
Give a very brief answer. 1.09. What is the ratio of the Number of refugees of Mauritius in 1998 to that in 2002?
Your answer should be very brief. 0.35. What is the ratio of the Number of refugees of Serbia in 1998 to that in 2002?
Your answer should be very brief. 0.35. What is the ratio of the Number of refugees in High income: OECD in 1998 to that in 2003?
Ensure brevity in your answer.  0.58. What is the ratio of the Number of refugees in Eritrea in 1998 to that in 2003?
Ensure brevity in your answer.  2.79. What is the ratio of the Number of refugees of Mauritius in 1998 to that in 2003?
Offer a very short reply. 0.25. What is the ratio of the Number of refugees in Serbia in 1998 to that in 2003?
Offer a very short reply. 0.39. What is the ratio of the Number of refugees in High income: OECD in 1998 to that in 2004?
Your response must be concise. 0.79. What is the ratio of the Number of refugees of Eritrea in 1998 to that in 2004?
Ensure brevity in your answer.  2.64. What is the ratio of the Number of refugees in Mauritius in 1998 to that in 2004?
Offer a terse response. 0.79. What is the ratio of the Number of refugees of Serbia in 1998 to that in 2004?
Ensure brevity in your answer.  0.49. What is the ratio of the Number of refugees in High income: OECD in 1998 to that in 2005?
Offer a very short reply. 0.57. What is the ratio of the Number of refugees in Eritrea in 1998 to that in 2005?
Your answer should be very brief. 2.41. What is the ratio of the Number of refugees in Mauritius in 1998 to that in 2005?
Provide a succinct answer. 0.56. What is the ratio of the Number of refugees in Serbia in 1998 to that in 2005?
Ensure brevity in your answer.  0.61. What is the ratio of the Number of refugees of High income: OECD in 1999 to that in 2000?
Make the answer very short. 1.21. What is the ratio of the Number of refugees of Eritrea in 1999 to that in 2000?
Your response must be concise. 0.92. What is the ratio of the Number of refugees of Mauritius in 1999 to that in 2000?
Offer a very short reply. 0.23. What is the ratio of the Number of refugees in Serbia in 1999 to that in 2000?
Your answer should be compact. 1.18. What is the ratio of the Number of refugees of High income: OECD in 1999 to that in 2001?
Give a very brief answer. 1.18. What is the ratio of the Number of refugees of Eritrea in 1999 to that in 2001?
Keep it short and to the point. 1.04. What is the ratio of the Number of refugees of Mauritius in 1999 to that in 2001?
Your response must be concise. 0.23. What is the ratio of the Number of refugees in Serbia in 1999 to that in 2001?
Ensure brevity in your answer.  1.2. What is the ratio of the Number of refugees of High income: OECD in 1999 to that in 2002?
Make the answer very short. 0.33. What is the ratio of the Number of refugees in Eritrea in 1999 to that in 2002?
Make the answer very short. 1.09. What is the ratio of the Number of refugees of Mauritius in 1999 to that in 2002?
Make the answer very short. 0.19. What is the ratio of the Number of refugees in Serbia in 1999 to that in 2002?
Provide a short and direct response. 0.53. What is the ratio of the Number of refugees of High income: OECD in 1999 to that in 2003?
Make the answer very short. 0.36. What is the ratio of the Number of refugees in Eritrea in 1999 to that in 2003?
Give a very brief answer. 2.8. What is the ratio of the Number of refugees of Mauritius in 1999 to that in 2003?
Your answer should be very brief. 0.13. What is the ratio of the Number of refugees in Serbia in 1999 to that in 2003?
Offer a very short reply. 0.58. What is the ratio of the Number of refugees of High income: OECD in 1999 to that in 2004?
Give a very brief answer. 0.49. What is the ratio of the Number of refugees of Eritrea in 1999 to that in 2004?
Your answer should be compact. 2.65. What is the ratio of the Number of refugees in Mauritius in 1999 to that in 2004?
Give a very brief answer. 0.42. What is the ratio of the Number of refugees of Serbia in 1999 to that in 2004?
Your answer should be very brief. 0.73. What is the ratio of the Number of refugees of High income: OECD in 1999 to that in 2005?
Offer a terse response. 0.35. What is the ratio of the Number of refugees of Eritrea in 1999 to that in 2005?
Ensure brevity in your answer.  2.41. What is the ratio of the Number of refugees in Mauritius in 1999 to that in 2005?
Provide a succinct answer. 0.3. What is the ratio of the Number of refugees in Serbia in 1999 to that in 2005?
Keep it short and to the point. 0.91. What is the ratio of the Number of refugees in High income: OECD in 2000 to that in 2001?
Your answer should be very brief. 0.98. What is the ratio of the Number of refugees of Eritrea in 2000 to that in 2001?
Provide a succinct answer. 1.13. What is the ratio of the Number of refugees of Serbia in 2000 to that in 2001?
Offer a very short reply. 1.02. What is the ratio of the Number of refugees in High income: OECD in 2000 to that in 2002?
Provide a succinct answer. 0.27. What is the ratio of the Number of refugees in Eritrea in 2000 to that in 2002?
Offer a very short reply. 1.18. What is the ratio of the Number of refugees of Mauritius in 2000 to that in 2002?
Ensure brevity in your answer.  0.81. What is the ratio of the Number of refugees in Serbia in 2000 to that in 2002?
Make the answer very short. 0.45. What is the ratio of the Number of refugees of High income: OECD in 2000 to that in 2003?
Provide a short and direct response. 0.3. What is the ratio of the Number of refugees of Eritrea in 2000 to that in 2003?
Offer a very short reply. 3.04. What is the ratio of the Number of refugees of Mauritius in 2000 to that in 2003?
Provide a succinct answer. 0.57. What is the ratio of the Number of refugees of Serbia in 2000 to that in 2003?
Ensure brevity in your answer.  0.49. What is the ratio of the Number of refugees of High income: OECD in 2000 to that in 2004?
Give a very brief answer. 0.4. What is the ratio of the Number of refugees of Eritrea in 2000 to that in 2004?
Ensure brevity in your answer.  2.87. What is the ratio of the Number of refugees of Mauritius in 2000 to that in 2004?
Your response must be concise. 1.84. What is the ratio of the Number of refugees in Serbia in 2000 to that in 2004?
Ensure brevity in your answer.  0.62. What is the ratio of the Number of refugees of High income: OECD in 2000 to that in 2005?
Offer a very short reply. 0.29. What is the ratio of the Number of refugees of Eritrea in 2000 to that in 2005?
Your answer should be compact. 2.62. What is the ratio of the Number of refugees of Mauritius in 2000 to that in 2005?
Keep it short and to the point. 1.3. What is the ratio of the Number of refugees in Serbia in 2000 to that in 2005?
Give a very brief answer. 0.77. What is the ratio of the Number of refugees of High income: OECD in 2001 to that in 2002?
Your response must be concise. 0.28. What is the ratio of the Number of refugees in Eritrea in 2001 to that in 2002?
Offer a very short reply. 1.05. What is the ratio of the Number of refugees in Mauritius in 2001 to that in 2002?
Make the answer very short. 0.81. What is the ratio of the Number of refugees in Serbia in 2001 to that in 2002?
Ensure brevity in your answer.  0.44. What is the ratio of the Number of refugees of High income: OECD in 2001 to that in 2003?
Your answer should be compact. 0.3. What is the ratio of the Number of refugees in Eritrea in 2001 to that in 2003?
Offer a terse response. 2.68. What is the ratio of the Number of refugees of Mauritius in 2001 to that in 2003?
Keep it short and to the point. 0.57. What is the ratio of the Number of refugees in Serbia in 2001 to that in 2003?
Keep it short and to the point. 0.49. What is the ratio of the Number of refugees in High income: OECD in 2001 to that in 2004?
Your answer should be very brief. 0.41. What is the ratio of the Number of refugees in Eritrea in 2001 to that in 2004?
Keep it short and to the point. 2.54. What is the ratio of the Number of refugees of Mauritius in 2001 to that in 2004?
Make the answer very short. 1.84. What is the ratio of the Number of refugees of Serbia in 2001 to that in 2004?
Offer a very short reply. 0.61. What is the ratio of the Number of refugees of High income: OECD in 2001 to that in 2005?
Offer a terse response. 0.3. What is the ratio of the Number of refugees in Eritrea in 2001 to that in 2005?
Provide a succinct answer. 2.31. What is the ratio of the Number of refugees in Mauritius in 2001 to that in 2005?
Provide a short and direct response. 1.3. What is the ratio of the Number of refugees of Serbia in 2001 to that in 2005?
Offer a very short reply. 0.76. What is the ratio of the Number of refugees of High income: OECD in 2002 to that in 2003?
Your answer should be very brief. 1.08. What is the ratio of the Number of refugees of Eritrea in 2002 to that in 2003?
Your response must be concise. 2.56. What is the ratio of the Number of refugees in Mauritius in 2002 to that in 2003?
Give a very brief answer. 0.7. What is the ratio of the Number of refugees in Serbia in 2002 to that in 2003?
Offer a very short reply. 1.1. What is the ratio of the Number of refugees of High income: OECD in 2002 to that in 2004?
Make the answer very short. 1.46. What is the ratio of the Number of refugees in Eritrea in 2002 to that in 2004?
Keep it short and to the point. 2.43. What is the ratio of the Number of refugees in Mauritius in 2002 to that in 2004?
Give a very brief answer. 2.26. What is the ratio of the Number of refugees in Serbia in 2002 to that in 2004?
Provide a succinct answer. 1.38. What is the ratio of the Number of refugees of High income: OECD in 2002 to that in 2005?
Ensure brevity in your answer.  1.06. What is the ratio of the Number of refugees of Eritrea in 2002 to that in 2005?
Your answer should be compact. 2.21. What is the ratio of the Number of refugees of Mauritius in 2002 to that in 2005?
Make the answer very short. 1.59. What is the ratio of the Number of refugees of Serbia in 2002 to that in 2005?
Ensure brevity in your answer.  1.72. What is the ratio of the Number of refugees in High income: OECD in 2003 to that in 2004?
Ensure brevity in your answer.  1.36. What is the ratio of the Number of refugees of Eritrea in 2003 to that in 2004?
Your answer should be compact. 0.95. What is the ratio of the Number of refugees in Mauritius in 2003 to that in 2004?
Offer a terse response. 3.21. What is the ratio of the Number of refugees in Serbia in 2003 to that in 2004?
Your answer should be compact. 1.25. What is the ratio of the Number of refugees of High income: OECD in 2003 to that in 2005?
Provide a succinct answer. 0.99. What is the ratio of the Number of refugees in Eritrea in 2003 to that in 2005?
Your answer should be compact. 0.86. What is the ratio of the Number of refugees in Mauritius in 2003 to that in 2005?
Keep it short and to the point. 2.26. What is the ratio of the Number of refugees of Serbia in 2003 to that in 2005?
Your response must be concise. 1.56. What is the ratio of the Number of refugees of High income: OECD in 2004 to that in 2005?
Your answer should be very brief. 0.72. What is the ratio of the Number of refugees in Eritrea in 2004 to that in 2005?
Provide a succinct answer. 0.91. What is the ratio of the Number of refugees of Mauritius in 2004 to that in 2005?
Provide a short and direct response. 0.7. What is the ratio of the Number of refugees in Serbia in 2004 to that in 2005?
Your answer should be compact. 1.25. What is the difference between the highest and the second highest Number of refugees in High income: OECD?
Keep it short and to the point. 2007. What is the difference between the highest and the second highest Number of refugees of Eritrea?
Ensure brevity in your answer.  2.97e+04. What is the difference between the highest and the second highest Number of refugees of Serbia?
Offer a terse response. 3.10e+04. What is the difference between the highest and the lowest Number of refugees in High income: OECD?
Ensure brevity in your answer.  2.52e+04. What is the difference between the highest and the lowest Number of refugees in Eritrea?
Your answer should be compact. 2.53e+05. What is the difference between the highest and the lowest Number of refugees in Serbia?
Make the answer very short. 2.12e+05. 